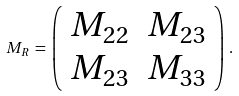<formula> <loc_0><loc_0><loc_500><loc_500>M _ { R } \, = \, \left ( \begin{array} { c c } M _ { 2 2 } & M _ { 2 3 } \\ M _ { 2 3 } & M _ { 3 3 } \end{array} \right ) \, .</formula> 